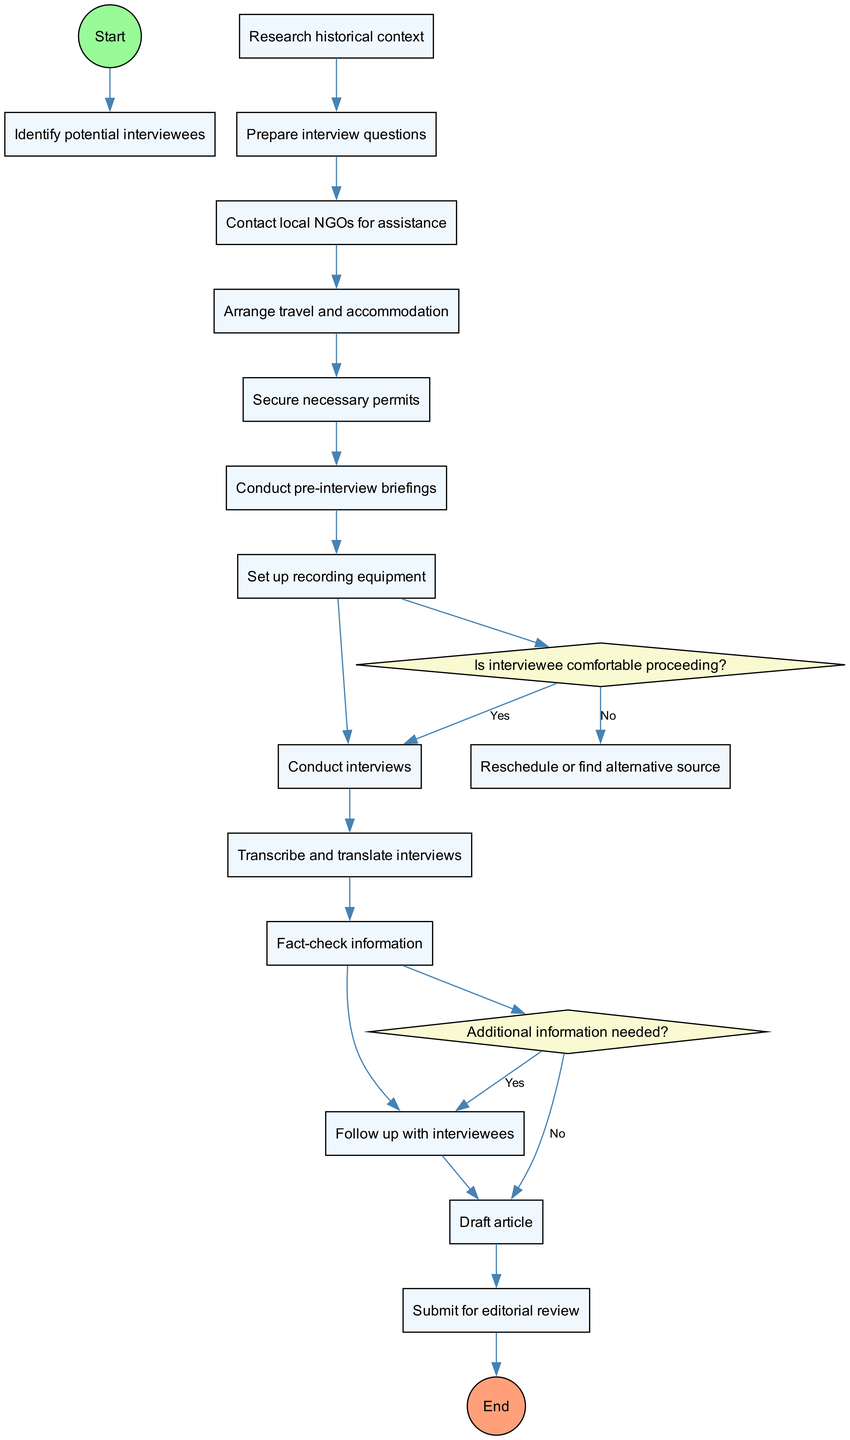What is the start node of the diagram? The start node is explicitly labeled in the diagram, indicating the beginning of the process. It is "Identify potential interviewees."
Answer: Identify potential interviewees How many activities are listed in the diagram? We count the number of nodes labeled as activities in the diagram. There are a total of 12 activities mentioned.
Answer: 12 What is the decision point related to the interviewee's comfort? The diagram includes a decision node that asks, "Is interviewee comfortable proceeding?" This is one of the key decision points in the process.
Answer: Is interviewee comfortable proceeding? Which activity precedes the "Conduct interviews" node? By examining the flow of activities, we see that "Conduct pre-interview briefings" directly connects to "Conduct interviews."
Answer: Conduct pre-interview briefings If the answer to the decision "Is interviewee comfortable proceeding?" is no, what action is taken next? The diagram indicates that if the interviewee is not comfortable, the process leads to "Reschedule or find alternative source." This is a clear outcome of the decision point.
Answer: Reschedule or find alternative source What happens if additional information is needed after the interviews? Referring to the decision node on whether additional information is needed, if the answer is yes, the process loops back to "Follow up with interviewees." This indicates a return to earlier steps for gathering further information.
Answer: Follow up with interviewees What is the end node of the diagram? The end node is marked clearly in the diagram designating the completion of the process. It reads "Publish article."
Answer: Publish article Which activity follows "Transcribe and translate interviews"? Following "Transcribe and translate interviews," the next activity listed in the diagram is "Fact-check information," demonstrating what step comes next in the flow.
Answer: Fact-check information How many decision nodes are present in the diagram? Upon analyzing the diagram, we can count the decision nodes. There are 2 decision nodes identified within the process flow described.
Answer: 2 